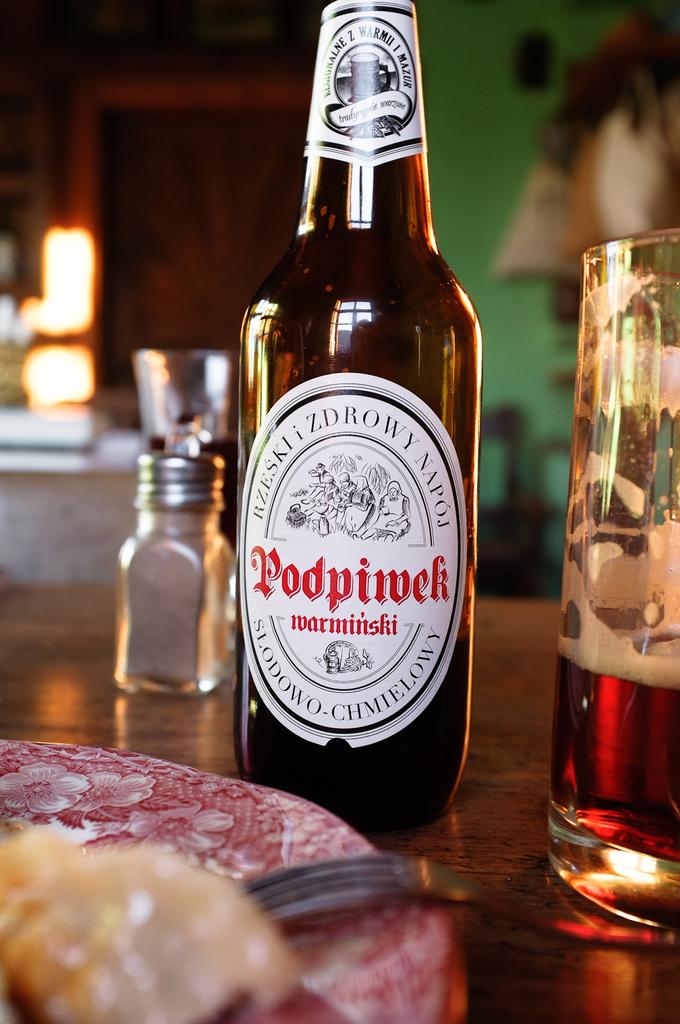What is the brand of beer?
Your answer should be very brief. Podpivek. What type of shaker is n the table?
Your answer should be compact. Answering does not require reading text in the image. 